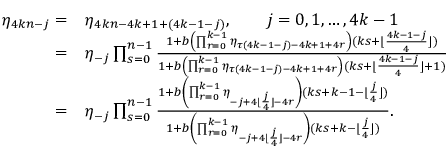<formula> <loc_0><loc_0><loc_500><loc_500>\begin{array} { r l } { \eta _ { 4 k n - j } = } & { \eta _ { 4 k n - 4 k + 1 + ( 4 k - 1 - j ) } , \quad j = 0 , 1 , \dots , 4 k - 1 } \\ { = } & { \eta _ { - j } \prod _ { s = 0 } ^ { n - 1 } \frac { 1 + b \left ( \prod _ { r = 0 } ^ { k - 1 } { \eta _ { \tau ( 4 k - 1 - j ) - 4 k + 1 + 4 r } } \right ) ( k s + \lfloor \frac { 4 k - 1 - j } { 4 } \rfloor ) } { 1 + b \left ( \prod _ { r = 0 } ^ { k - 1 } { \eta _ { \tau ( 4 k - 1 - j ) - 4 k + 1 + 4 r } } \right ) ( k s + \lfloor \frac { 4 k - 1 - j } { 4 } \rfloor + 1 ) } } \\ { = } & { \eta _ { - j } \prod _ { s = 0 } ^ { n - 1 } \frac { 1 + b \left ( \prod _ { r = 0 } ^ { k - 1 } { \eta _ { - j + 4 \lfloor \frac { j } { 4 } \rfloor - 4 r } } \right ) ( k s + k - 1 - \lfloor \frac { j } { 4 } \rfloor ) } { 1 + b \left ( \prod _ { r = 0 } ^ { k - 1 } { \eta _ { - j + 4 \lfloor \frac { j } { 4 } \rfloor - 4 r } } \right ) ( k s + k - \lfloor \frac { j } { 4 } \rfloor ) } . } \end{array}</formula> 